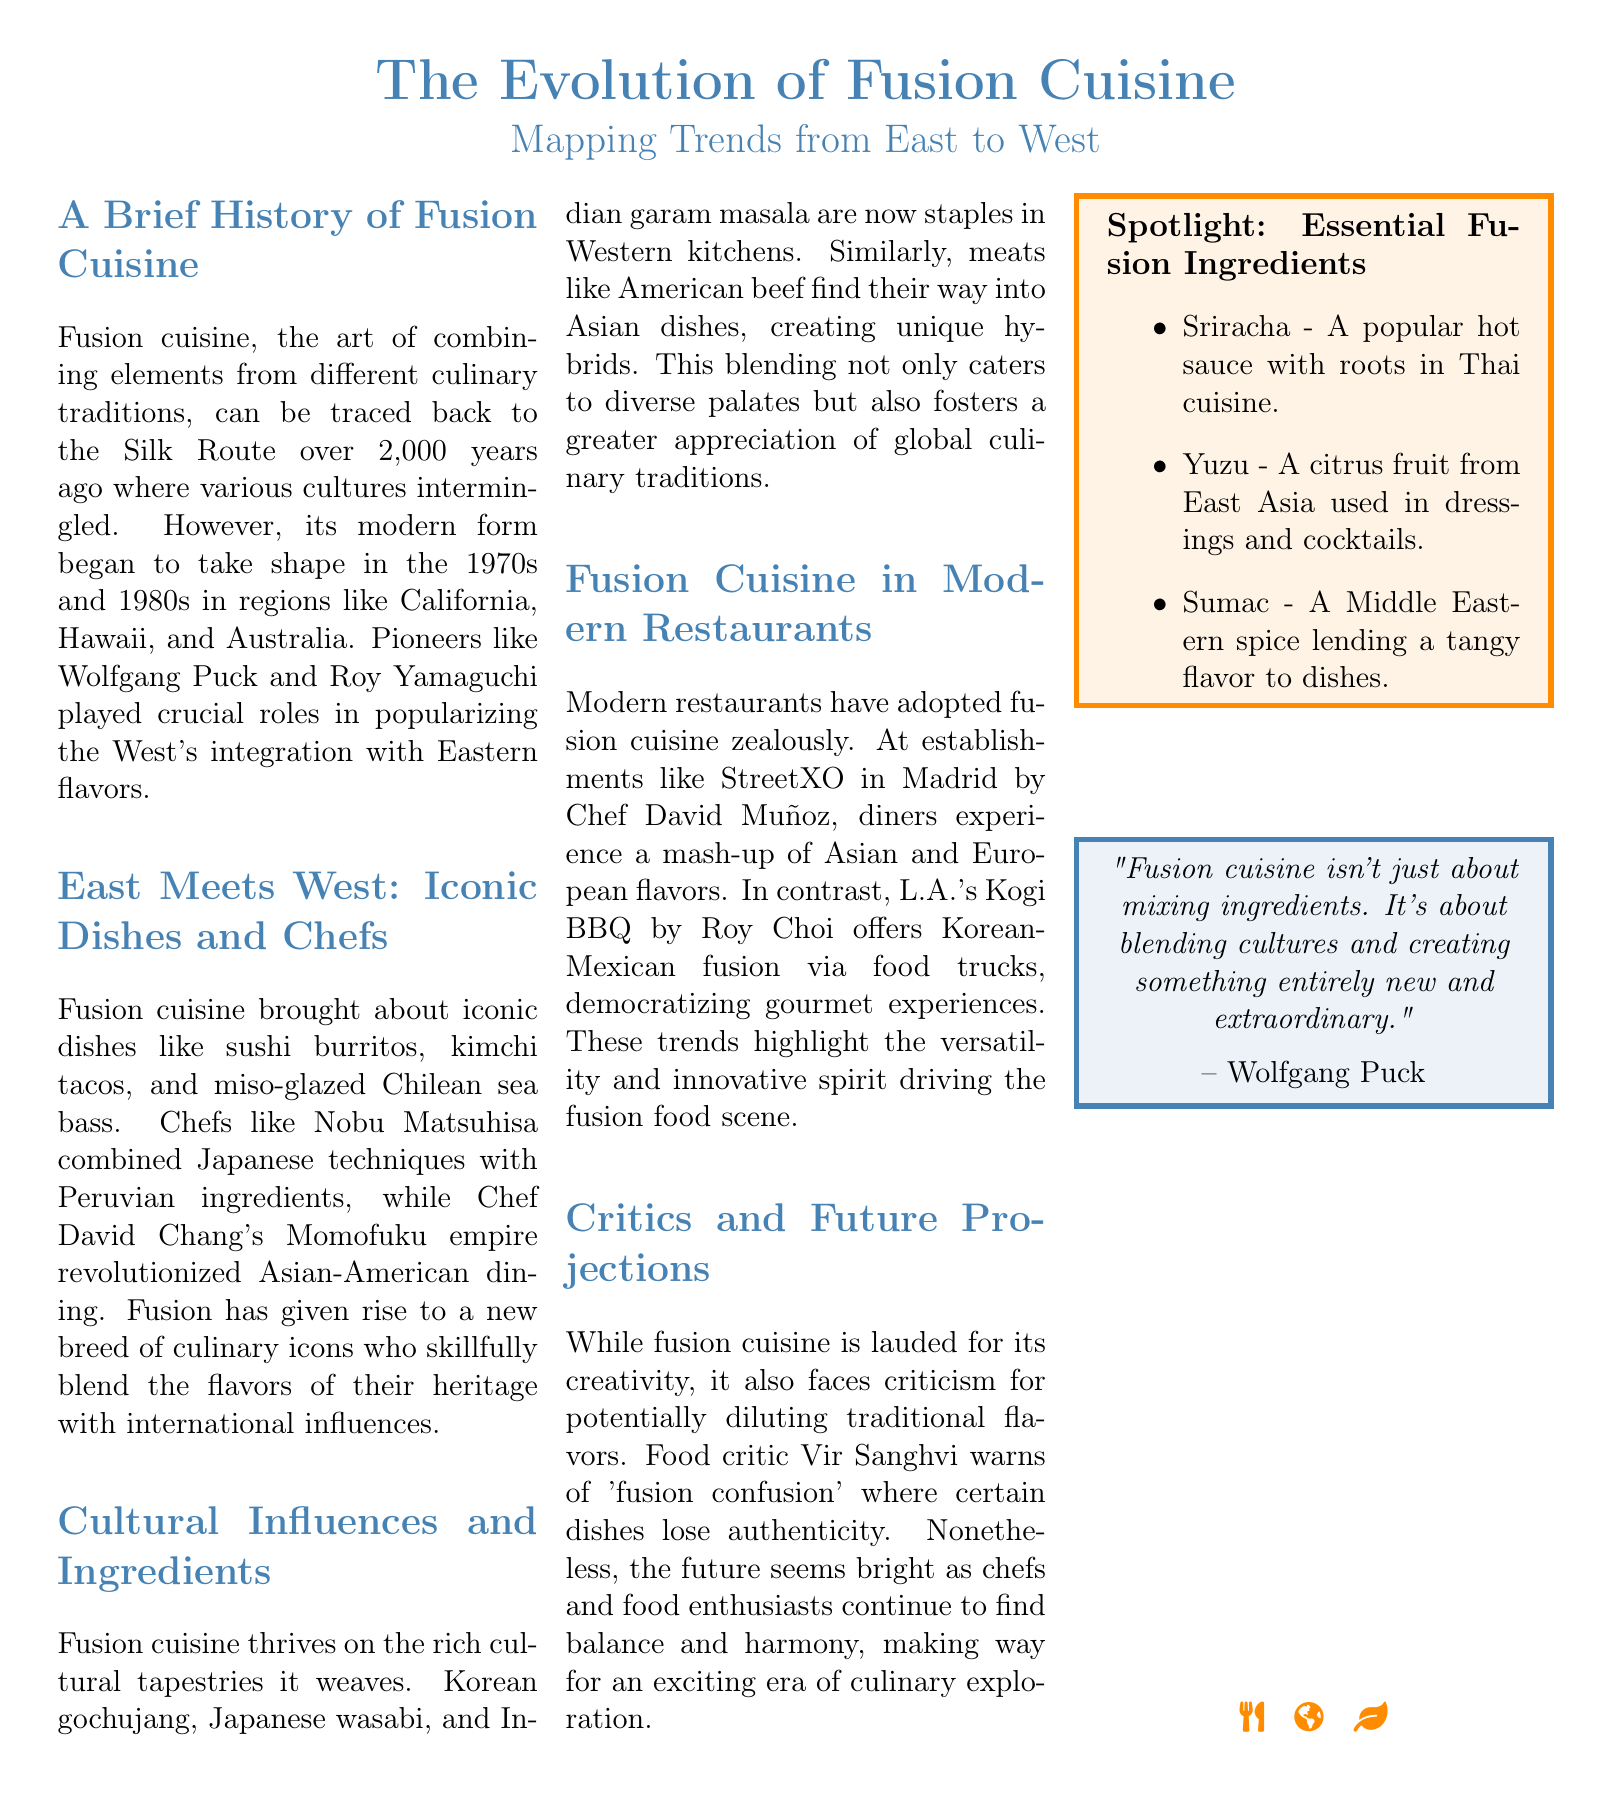What decade did modern fusion cuisine begin to take shape? The text states that modern fusion cuisine began to take shape in the 1970s and 1980s.
Answer: 1970s and 1980s Who is a noted chef that combined Japanese techniques with Peruvian ingredients? The document mentions Chef Nobu Matsuhisa as a chef who combines Japanese techniques with Peruvian ingredients.
Answer: Nobu Matsuhisa What is one of the iconic dishes mentioned in the document? The document lists sushi burritos, kimchi tacos, and miso-glazed Chilean sea bass as iconic dishes.
Answer: sushi burritos Which hot sauce is highlighted as an essential fusion ingredient? The sidebar identifies Sriracha as a popular hot sauce rooted in Thai cuisine.
Answer: Sriracha What term does food critic Vir Sanghvi use to describe potential issues with fusion cuisine? The text mentions Vir Sanghvi warns of 'fusion confusion' in reference to dilution of traditional flavors.
Answer: fusion confusion What restaurant in Madrid is known for its fusion cuisine? StreetXO in Madrid is noted for its mash-up of Asian and European flavors.
Answer: StreetXO How does the document describe the approach of modern restaurants towards fusion cuisine? The document states that modern restaurants have adopted fusion cuisine zealously, indicating enthusiasm.
Answer: zealously What is emphasized about fusion cuisine according to Wolfgang Puck? Wolfgang Puck emphasizes that fusion cuisine is about blending cultures and creating something new.
Answer: blending cultures 